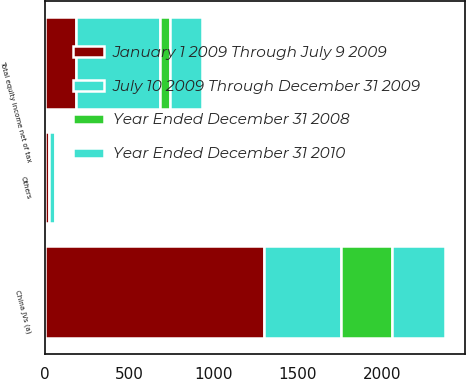<chart> <loc_0><loc_0><loc_500><loc_500><stacked_bar_chart><ecel><fcel>China JVs (a)<fcel>Others<fcel>Total equity income net of tax<nl><fcel>January 1 2009 Through July 9 2009<fcel>1297<fcel>24<fcel>186<nl><fcel>July 10 2009 Through December 31 2009<fcel>460<fcel>38<fcel>497<nl><fcel>Year Ended December 31 2008<fcel>300<fcel>4<fcel>61<nl><fcel>Year Ended December 31 2010<fcel>315<fcel>11<fcel>186<nl></chart> 